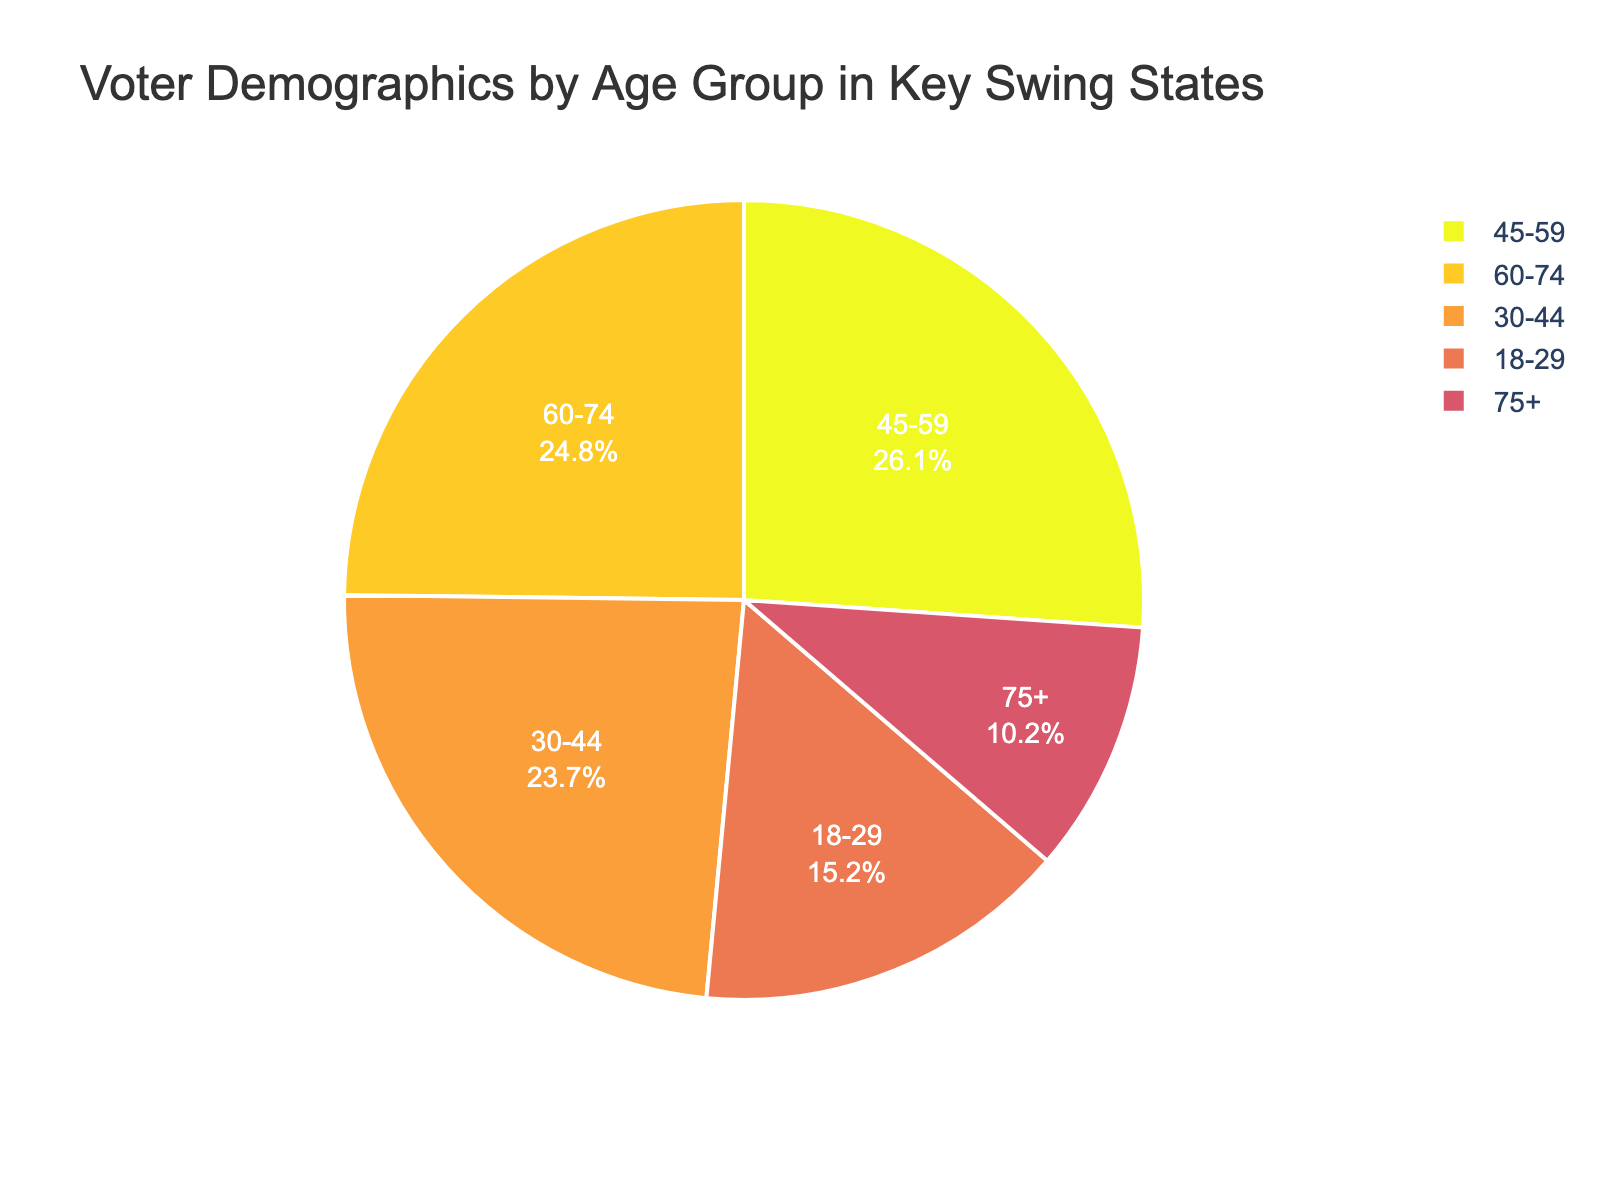What age group has the highest percentage of voter demographics? By looking at the pie chart, the age group '45-59' has the highest percentage.
Answer: 45-59 How much more percentage does the '60-74' age group have compared to the '18-29' age group? The '60-74' age group has 24.8%, and the '18-29' age group has 15.2%. The difference is 24.8% - 15.2% = 9.6%.
Answer: 9.6% Which age group has the lowest percentage of voter demographics? By observing the pie chart, the '75+' age group has the lowest percentage at 10.2%.
Answer: 75+ What is the sum of the percentages of the youngest two age groups ('18-29' and '30-44')? The '18-29' age group has 15.2%, and the '30-44' age group has 23.7%. The sum is 15.2% + 23.7% = 38.9%.
Answer: 38.9% How does the percentage of the '45-59' age group compare to the '60-74' age group? The '45-59' age group has a percentage of 26.1%, while the '60-74' age group has a percentage of 24.8%. The '45-59' group has a higher percentage.
Answer: The '45-59' group has a higher percentage What is the difference between the highest and lowest voter demographic percentages? The highest percentage is 26.1% (45-59 age group), and the lowest is 10.2% (75+ age group). The difference is 26.1% - 10.2% = 15.9%.
Answer: 15.9% What are the combined percentages of age groups 45-59 and 60-74? The '45-59' group has 26.1%, and the '60-74' group has 24.8%. The combined percentage is 26.1% + 24.8% = 50.9%.
Answer: 50.9% How does the percentage of the '30-44' age group compare to the combined percentage of the '18-29' and '75+' age groups? The '30-44' age group has 23.7%. The combined percentage of '18-29' (15.2%) and '75+' (10.2%) is 15.2% + 10.2% = 25.4%. The '30-44' age group has a lower percentage.
Answer: The '30-44' group has a lower percentage What is the proportion of voters aged 45 and above compared to those below 45? Voters aged 45 and above include groups '45-59', '60-74', and '75+' with percentages 26.1%, 24.8%, and 10.2%, respectively. Their combined percentage is 26.1% + 24.8% + 10.2% = 61.1%. Voters below 45 include '18-29' and '30-44' with percentages 15.2% and 23.7%, respectively. Their combined percentage is 15.2% + 23.7% = 38.9%.
Answer: 61.1% for 45 and above, 38.9% for below 45 